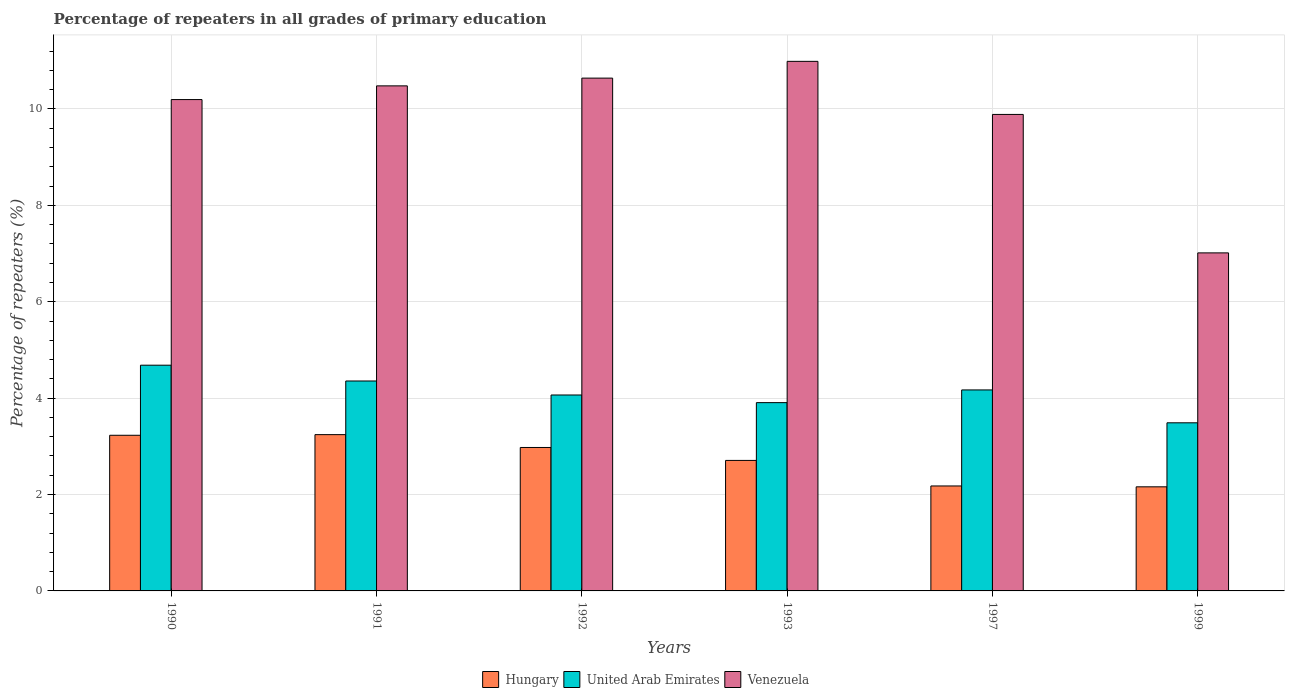How many bars are there on the 5th tick from the right?
Provide a short and direct response. 3. What is the percentage of repeaters in Hungary in 1993?
Your answer should be very brief. 2.71. Across all years, what is the maximum percentage of repeaters in United Arab Emirates?
Make the answer very short. 4.68. Across all years, what is the minimum percentage of repeaters in Hungary?
Your answer should be very brief. 2.16. In which year was the percentage of repeaters in Hungary maximum?
Provide a succinct answer. 1991. In which year was the percentage of repeaters in Venezuela minimum?
Ensure brevity in your answer.  1999. What is the total percentage of repeaters in Venezuela in the graph?
Provide a succinct answer. 59.21. What is the difference between the percentage of repeaters in Hungary in 1992 and that in 1999?
Your answer should be very brief. 0.82. What is the difference between the percentage of repeaters in Venezuela in 1992 and the percentage of repeaters in Hungary in 1999?
Keep it short and to the point. 8.48. What is the average percentage of repeaters in Hungary per year?
Make the answer very short. 2.75. In the year 1991, what is the difference between the percentage of repeaters in Hungary and percentage of repeaters in United Arab Emirates?
Make the answer very short. -1.11. What is the ratio of the percentage of repeaters in United Arab Emirates in 1990 to that in 1992?
Your response must be concise. 1.15. Is the percentage of repeaters in Venezuela in 1992 less than that in 1999?
Your answer should be compact. No. What is the difference between the highest and the second highest percentage of repeaters in United Arab Emirates?
Keep it short and to the point. 0.33. What is the difference between the highest and the lowest percentage of repeaters in United Arab Emirates?
Your response must be concise. 1.2. Is the sum of the percentage of repeaters in Venezuela in 1991 and 1999 greater than the maximum percentage of repeaters in Hungary across all years?
Your answer should be very brief. Yes. What does the 2nd bar from the left in 1999 represents?
Offer a very short reply. United Arab Emirates. What does the 3rd bar from the right in 1990 represents?
Offer a very short reply. Hungary. How many bars are there?
Your response must be concise. 18. Are all the bars in the graph horizontal?
Your answer should be compact. No. How many years are there in the graph?
Provide a short and direct response. 6. What is the difference between two consecutive major ticks on the Y-axis?
Offer a very short reply. 2. Are the values on the major ticks of Y-axis written in scientific E-notation?
Your answer should be compact. No. Does the graph contain any zero values?
Your response must be concise. No. Does the graph contain grids?
Your answer should be compact. Yes. Where does the legend appear in the graph?
Your response must be concise. Bottom center. What is the title of the graph?
Make the answer very short. Percentage of repeaters in all grades of primary education. Does "Kazakhstan" appear as one of the legend labels in the graph?
Ensure brevity in your answer.  No. What is the label or title of the Y-axis?
Give a very brief answer. Percentage of repeaters (%). What is the Percentage of repeaters (%) of Hungary in 1990?
Your answer should be very brief. 3.23. What is the Percentage of repeaters (%) of United Arab Emirates in 1990?
Your answer should be compact. 4.68. What is the Percentage of repeaters (%) in Venezuela in 1990?
Your response must be concise. 10.2. What is the Percentage of repeaters (%) of Hungary in 1991?
Your response must be concise. 3.24. What is the Percentage of repeaters (%) in United Arab Emirates in 1991?
Offer a terse response. 4.36. What is the Percentage of repeaters (%) of Venezuela in 1991?
Keep it short and to the point. 10.48. What is the Percentage of repeaters (%) of Hungary in 1992?
Keep it short and to the point. 2.98. What is the Percentage of repeaters (%) of United Arab Emirates in 1992?
Provide a succinct answer. 4.07. What is the Percentage of repeaters (%) of Venezuela in 1992?
Ensure brevity in your answer.  10.64. What is the Percentage of repeaters (%) of Hungary in 1993?
Provide a short and direct response. 2.71. What is the Percentage of repeaters (%) of United Arab Emirates in 1993?
Make the answer very short. 3.91. What is the Percentage of repeaters (%) in Venezuela in 1993?
Your answer should be compact. 10.99. What is the Percentage of repeaters (%) of Hungary in 1997?
Offer a terse response. 2.18. What is the Percentage of repeaters (%) of United Arab Emirates in 1997?
Offer a very short reply. 4.17. What is the Percentage of repeaters (%) of Venezuela in 1997?
Provide a succinct answer. 9.89. What is the Percentage of repeaters (%) of Hungary in 1999?
Provide a succinct answer. 2.16. What is the Percentage of repeaters (%) in United Arab Emirates in 1999?
Your answer should be compact. 3.49. What is the Percentage of repeaters (%) of Venezuela in 1999?
Ensure brevity in your answer.  7.01. Across all years, what is the maximum Percentage of repeaters (%) in Hungary?
Make the answer very short. 3.24. Across all years, what is the maximum Percentage of repeaters (%) in United Arab Emirates?
Make the answer very short. 4.68. Across all years, what is the maximum Percentage of repeaters (%) in Venezuela?
Provide a short and direct response. 10.99. Across all years, what is the minimum Percentage of repeaters (%) in Hungary?
Your response must be concise. 2.16. Across all years, what is the minimum Percentage of repeaters (%) of United Arab Emirates?
Offer a terse response. 3.49. Across all years, what is the minimum Percentage of repeaters (%) of Venezuela?
Ensure brevity in your answer.  7.01. What is the total Percentage of repeaters (%) of Hungary in the graph?
Provide a short and direct response. 16.5. What is the total Percentage of repeaters (%) of United Arab Emirates in the graph?
Keep it short and to the point. 24.67. What is the total Percentage of repeaters (%) in Venezuela in the graph?
Your answer should be compact. 59.21. What is the difference between the Percentage of repeaters (%) of Hungary in 1990 and that in 1991?
Offer a terse response. -0.01. What is the difference between the Percentage of repeaters (%) of United Arab Emirates in 1990 and that in 1991?
Your response must be concise. 0.33. What is the difference between the Percentage of repeaters (%) in Venezuela in 1990 and that in 1991?
Your answer should be compact. -0.28. What is the difference between the Percentage of repeaters (%) of Hungary in 1990 and that in 1992?
Ensure brevity in your answer.  0.25. What is the difference between the Percentage of repeaters (%) in United Arab Emirates in 1990 and that in 1992?
Give a very brief answer. 0.62. What is the difference between the Percentage of repeaters (%) in Venezuela in 1990 and that in 1992?
Your response must be concise. -0.45. What is the difference between the Percentage of repeaters (%) in Hungary in 1990 and that in 1993?
Provide a short and direct response. 0.52. What is the difference between the Percentage of repeaters (%) of United Arab Emirates in 1990 and that in 1993?
Provide a succinct answer. 0.78. What is the difference between the Percentage of repeaters (%) in Venezuela in 1990 and that in 1993?
Provide a succinct answer. -0.79. What is the difference between the Percentage of repeaters (%) in Hungary in 1990 and that in 1997?
Provide a succinct answer. 1.05. What is the difference between the Percentage of repeaters (%) of United Arab Emirates in 1990 and that in 1997?
Your response must be concise. 0.51. What is the difference between the Percentage of repeaters (%) of Venezuela in 1990 and that in 1997?
Keep it short and to the point. 0.31. What is the difference between the Percentage of repeaters (%) of Hungary in 1990 and that in 1999?
Your answer should be very brief. 1.07. What is the difference between the Percentage of repeaters (%) of United Arab Emirates in 1990 and that in 1999?
Offer a very short reply. 1.2. What is the difference between the Percentage of repeaters (%) in Venezuela in 1990 and that in 1999?
Keep it short and to the point. 3.18. What is the difference between the Percentage of repeaters (%) in Hungary in 1991 and that in 1992?
Your answer should be very brief. 0.27. What is the difference between the Percentage of repeaters (%) of United Arab Emirates in 1991 and that in 1992?
Make the answer very short. 0.29. What is the difference between the Percentage of repeaters (%) of Venezuela in 1991 and that in 1992?
Give a very brief answer. -0.16. What is the difference between the Percentage of repeaters (%) of Hungary in 1991 and that in 1993?
Offer a very short reply. 0.54. What is the difference between the Percentage of repeaters (%) of United Arab Emirates in 1991 and that in 1993?
Provide a succinct answer. 0.45. What is the difference between the Percentage of repeaters (%) of Venezuela in 1991 and that in 1993?
Keep it short and to the point. -0.51. What is the difference between the Percentage of repeaters (%) in Hungary in 1991 and that in 1997?
Offer a very short reply. 1.06. What is the difference between the Percentage of repeaters (%) in United Arab Emirates in 1991 and that in 1997?
Ensure brevity in your answer.  0.19. What is the difference between the Percentage of repeaters (%) in Venezuela in 1991 and that in 1997?
Your answer should be very brief. 0.59. What is the difference between the Percentage of repeaters (%) in Hungary in 1991 and that in 1999?
Your response must be concise. 1.08. What is the difference between the Percentage of repeaters (%) of United Arab Emirates in 1991 and that in 1999?
Keep it short and to the point. 0.87. What is the difference between the Percentage of repeaters (%) of Venezuela in 1991 and that in 1999?
Your answer should be compact. 3.47. What is the difference between the Percentage of repeaters (%) in Hungary in 1992 and that in 1993?
Provide a succinct answer. 0.27. What is the difference between the Percentage of repeaters (%) of United Arab Emirates in 1992 and that in 1993?
Offer a very short reply. 0.16. What is the difference between the Percentage of repeaters (%) of Venezuela in 1992 and that in 1993?
Give a very brief answer. -0.35. What is the difference between the Percentage of repeaters (%) of Hungary in 1992 and that in 1997?
Ensure brevity in your answer.  0.8. What is the difference between the Percentage of repeaters (%) in United Arab Emirates in 1992 and that in 1997?
Your answer should be compact. -0.1. What is the difference between the Percentage of repeaters (%) of Venezuela in 1992 and that in 1997?
Provide a short and direct response. 0.75. What is the difference between the Percentage of repeaters (%) of Hungary in 1992 and that in 1999?
Your answer should be very brief. 0.82. What is the difference between the Percentage of repeaters (%) in United Arab Emirates in 1992 and that in 1999?
Your answer should be compact. 0.58. What is the difference between the Percentage of repeaters (%) of Venezuela in 1992 and that in 1999?
Your answer should be compact. 3.63. What is the difference between the Percentage of repeaters (%) in Hungary in 1993 and that in 1997?
Provide a short and direct response. 0.53. What is the difference between the Percentage of repeaters (%) of United Arab Emirates in 1993 and that in 1997?
Ensure brevity in your answer.  -0.26. What is the difference between the Percentage of repeaters (%) in Venezuela in 1993 and that in 1997?
Give a very brief answer. 1.1. What is the difference between the Percentage of repeaters (%) of Hungary in 1993 and that in 1999?
Your response must be concise. 0.55. What is the difference between the Percentage of repeaters (%) of United Arab Emirates in 1993 and that in 1999?
Provide a short and direct response. 0.42. What is the difference between the Percentage of repeaters (%) in Venezuela in 1993 and that in 1999?
Provide a succinct answer. 3.97. What is the difference between the Percentage of repeaters (%) in Hungary in 1997 and that in 1999?
Your answer should be very brief. 0.02. What is the difference between the Percentage of repeaters (%) in United Arab Emirates in 1997 and that in 1999?
Ensure brevity in your answer.  0.68. What is the difference between the Percentage of repeaters (%) in Venezuela in 1997 and that in 1999?
Give a very brief answer. 2.87. What is the difference between the Percentage of repeaters (%) in Hungary in 1990 and the Percentage of repeaters (%) in United Arab Emirates in 1991?
Make the answer very short. -1.13. What is the difference between the Percentage of repeaters (%) of Hungary in 1990 and the Percentage of repeaters (%) of Venezuela in 1991?
Your answer should be very brief. -7.25. What is the difference between the Percentage of repeaters (%) of United Arab Emirates in 1990 and the Percentage of repeaters (%) of Venezuela in 1991?
Provide a short and direct response. -5.8. What is the difference between the Percentage of repeaters (%) in Hungary in 1990 and the Percentage of repeaters (%) in United Arab Emirates in 1992?
Give a very brief answer. -0.84. What is the difference between the Percentage of repeaters (%) in Hungary in 1990 and the Percentage of repeaters (%) in Venezuela in 1992?
Your response must be concise. -7.41. What is the difference between the Percentage of repeaters (%) in United Arab Emirates in 1990 and the Percentage of repeaters (%) in Venezuela in 1992?
Your response must be concise. -5.96. What is the difference between the Percentage of repeaters (%) in Hungary in 1990 and the Percentage of repeaters (%) in United Arab Emirates in 1993?
Give a very brief answer. -0.68. What is the difference between the Percentage of repeaters (%) in Hungary in 1990 and the Percentage of repeaters (%) in Venezuela in 1993?
Make the answer very short. -7.76. What is the difference between the Percentage of repeaters (%) in United Arab Emirates in 1990 and the Percentage of repeaters (%) in Venezuela in 1993?
Make the answer very short. -6.3. What is the difference between the Percentage of repeaters (%) of Hungary in 1990 and the Percentage of repeaters (%) of United Arab Emirates in 1997?
Provide a succinct answer. -0.94. What is the difference between the Percentage of repeaters (%) in Hungary in 1990 and the Percentage of repeaters (%) in Venezuela in 1997?
Keep it short and to the point. -6.66. What is the difference between the Percentage of repeaters (%) of United Arab Emirates in 1990 and the Percentage of repeaters (%) of Venezuela in 1997?
Give a very brief answer. -5.2. What is the difference between the Percentage of repeaters (%) of Hungary in 1990 and the Percentage of repeaters (%) of United Arab Emirates in 1999?
Give a very brief answer. -0.26. What is the difference between the Percentage of repeaters (%) of Hungary in 1990 and the Percentage of repeaters (%) of Venezuela in 1999?
Ensure brevity in your answer.  -3.78. What is the difference between the Percentage of repeaters (%) in United Arab Emirates in 1990 and the Percentage of repeaters (%) in Venezuela in 1999?
Keep it short and to the point. -2.33. What is the difference between the Percentage of repeaters (%) of Hungary in 1991 and the Percentage of repeaters (%) of United Arab Emirates in 1992?
Offer a terse response. -0.82. What is the difference between the Percentage of repeaters (%) of Hungary in 1991 and the Percentage of repeaters (%) of Venezuela in 1992?
Your answer should be very brief. -7.4. What is the difference between the Percentage of repeaters (%) in United Arab Emirates in 1991 and the Percentage of repeaters (%) in Venezuela in 1992?
Provide a short and direct response. -6.28. What is the difference between the Percentage of repeaters (%) of Hungary in 1991 and the Percentage of repeaters (%) of United Arab Emirates in 1993?
Your response must be concise. -0.66. What is the difference between the Percentage of repeaters (%) in Hungary in 1991 and the Percentage of repeaters (%) in Venezuela in 1993?
Keep it short and to the point. -7.75. What is the difference between the Percentage of repeaters (%) of United Arab Emirates in 1991 and the Percentage of repeaters (%) of Venezuela in 1993?
Give a very brief answer. -6.63. What is the difference between the Percentage of repeaters (%) of Hungary in 1991 and the Percentage of repeaters (%) of United Arab Emirates in 1997?
Provide a succinct answer. -0.93. What is the difference between the Percentage of repeaters (%) of Hungary in 1991 and the Percentage of repeaters (%) of Venezuela in 1997?
Keep it short and to the point. -6.64. What is the difference between the Percentage of repeaters (%) in United Arab Emirates in 1991 and the Percentage of repeaters (%) in Venezuela in 1997?
Keep it short and to the point. -5.53. What is the difference between the Percentage of repeaters (%) of Hungary in 1991 and the Percentage of repeaters (%) of United Arab Emirates in 1999?
Your response must be concise. -0.25. What is the difference between the Percentage of repeaters (%) of Hungary in 1991 and the Percentage of repeaters (%) of Venezuela in 1999?
Make the answer very short. -3.77. What is the difference between the Percentage of repeaters (%) of United Arab Emirates in 1991 and the Percentage of repeaters (%) of Venezuela in 1999?
Your answer should be very brief. -2.66. What is the difference between the Percentage of repeaters (%) of Hungary in 1992 and the Percentage of repeaters (%) of United Arab Emirates in 1993?
Your response must be concise. -0.93. What is the difference between the Percentage of repeaters (%) of Hungary in 1992 and the Percentage of repeaters (%) of Venezuela in 1993?
Make the answer very short. -8.01. What is the difference between the Percentage of repeaters (%) of United Arab Emirates in 1992 and the Percentage of repeaters (%) of Venezuela in 1993?
Keep it short and to the point. -6.92. What is the difference between the Percentage of repeaters (%) of Hungary in 1992 and the Percentage of repeaters (%) of United Arab Emirates in 1997?
Keep it short and to the point. -1.19. What is the difference between the Percentage of repeaters (%) in Hungary in 1992 and the Percentage of repeaters (%) in Venezuela in 1997?
Offer a terse response. -6.91. What is the difference between the Percentage of repeaters (%) of United Arab Emirates in 1992 and the Percentage of repeaters (%) of Venezuela in 1997?
Offer a very short reply. -5.82. What is the difference between the Percentage of repeaters (%) of Hungary in 1992 and the Percentage of repeaters (%) of United Arab Emirates in 1999?
Your answer should be compact. -0.51. What is the difference between the Percentage of repeaters (%) of Hungary in 1992 and the Percentage of repeaters (%) of Venezuela in 1999?
Offer a terse response. -4.04. What is the difference between the Percentage of repeaters (%) of United Arab Emirates in 1992 and the Percentage of repeaters (%) of Venezuela in 1999?
Provide a short and direct response. -2.95. What is the difference between the Percentage of repeaters (%) of Hungary in 1993 and the Percentage of repeaters (%) of United Arab Emirates in 1997?
Your answer should be very brief. -1.46. What is the difference between the Percentage of repeaters (%) in Hungary in 1993 and the Percentage of repeaters (%) in Venezuela in 1997?
Your response must be concise. -7.18. What is the difference between the Percentage of repeaters (%) of United Arab Emirates in 1993 and the Percentage of repeaters (%) of Venezuela in 1997?
Provide a succinct answer. -5.98. What is the difference between the Percentage of repeaters (%) in Hungary in 1993 and the Percentage of repeaters (%) in United Arab Emirates in 1999?
Your answer should be very brief. -0.78. What is the difference between the Percentage of repeaters (%) of Hungary in 1993 and the Percentage of repeaters (%) of Venezuela in 1999?
Your response must be concise. -4.31. What is the difference between the Percentage of repeaters (%) of United Arab Emirates in 1993 and the Percentage of repeaters (%) of Venezuela in 1999?
Ensure brevity in your answer.  -3.11. What is the difference between the Percentage of repeaters (%) of Hungary in 1997 and the Percentage of repeaters (%) of United Arab Emirates in 1999?
Offer a terse response. -1.31. What is the difference between the Percentage of repeaters (%) in Hungary in 1997 and the Percentage of repeaters (%) in Venezuela in 1999?
Provide a short and direct response. -4.84. What is the difference between the Percentage of repeaters (%) in United Arab Emirates in 1997 and the Percentage of repeaters (%) in Venezuela in 1999?
Your response must be concise. -2.84. What is the average Percentage of repeaters (%) in Hungary per year?
Your answer should be compact. 2.75. What is the average Percentage of repeaters (%) in United Arab Emirates per year?
Your answer should be very brief. 4.11. What is the average Percentage of repeaters (%) in Venezuela per year?
Your answer should be very brief. 9.87. In the year 1990, what is the difference between the Percentage of repeaters (%) of Hungary and Percentage of repeaters (%) of United Arab Emirates?
Make the answer very short. -1.45. In the year 1990, what is the difference between the Percentage of repeaters (%) in Hungary and Percentage of repeaters (%) in Venezuela?
Your answer should be very brief. -6.97. In the year 1990, what is the difference between the Percentage of repeaters (%) in United Arab Emirates and Percentage of repeaters (%) in Venezuela?
Make the answer very short. -5.51. In the year 1991, what is the difference between the Percentage of repeaters (%) of Hungary and Percentage of repeaters (%) of United Arab Emirates?
Make the answer very short. -1.11. In the year 1991, what is the difference between the Percentage of repeaters (%) of Hungary and Percentage of repeaters (%) of Venezuela?
Give a very brief answer. -7.24. In the year 1991, what is the difference between the Percentage of repeaters (%) of United Arab Emirates and Percentage of repeaters (%) of Venezuela?
Offer a terse response. -6.12. In the year 1992, what is the difference between the Percentage of repeaters (%) in Hungary and Percentage of repeaters (%) in United Arab Emirates?
Make the answer very short. -1.09. In the year 1992, what is the difference between the Percentage of repeaters (%) in Hungary and Percentage of repeaters (%) in Venezuela?
Provide a short and direct response. -7.66. In the year 1992, what is the difference between the Percentage of repeaters (%) of United Arab Emirates and Percentage of repeaters (%) of Venezuela?
Your response must be concise. -6.58. In the year 1993, what is the difference between the Percentage of repeaters (%) in Hungary and Percentage of repeaters (%) in United Arab Emirates?
Offer a very short reply. -1.2. In the year 1993, what is the difference between the Percentage of repeaters (%) of Hungary and Percentage of repeaters (%) of Venezuela?
Make the answer very short. -8.28. In the year 1993, what is the difference between the Percentage of repeaters (%) of United Arab Emirates and Percentage of repeaters (%) of Venezuela?
Offer a terse response. -7.08. In the year 1997, what is the difference between the Percentage of repeaters (%) of Hungary and Percentage of repeaters (%) of United Arab Emirates?
Provide a short and direct response. -1.99. In the year 1997, what is the difference between the Percentage of repeaters (%) of Hungary and Percentage of repeaters (%) of Venezuela?
Your answer should be compact. -7.71. In the year 1997, what is the difference between the Percentage of repeaters (%) of United Arab Emirates and Percentage of repeaters (%) of Venezuela?
Your answer should be compact. -5.72. In the year 1999, what is the difference between the Percentage of repeaters (%) in Hungary and Percentage of repeaters (%) in United Arab Emirates?
Make the answer very short. -1.33. In the year 1999, what is the difference between the Percentage of repeaters (%) in Hungary and Percentage of repeaters (%) in Venezuela?
Offer a very short reply. -4.85. In the year 1999, what is the difference between the Percentage of repeaters (%) in United Arab Emirates and Percentage of repeaters (%) in Venezuela?
Provide a short and direct response. -3.53. What is the ratio of the Percentage of repeaters (%) in United Arab Emirates in 1990 to that in 1991?
Offer a terse response. 1.08. What is the ratio of the Percentage of repeaters (%) in Venezuela in 1990 to that in 1991?
Your answer should be very brief. 0.97. What is the ratio of the Percentage of repeaters (%) of Hungary in 1990 to that in 1992?
Your answer should be very brief. 1.08. What is the ratio of the Percentage of repeaters (%) of United Arab Emirates in 1990 to that in 1992?
Ensure brevity in your answer.  1.15. What is the ratio of the Percentage of repeaters (%) of Venezuela in 1990 to that in 1992?
Ensure brevity in your answer.  0.96. What is the ratio of the Percentage of repeaters (%) of Hungary in 1990 to that in 1993?
Give a very brief answer. 1.19. What is the ratio of the Percentage of repeaters (%) of United Arab Emirates in 1990 to that in 1993?
Give a very brief answer. 1.2. What is the ratio of the Percentage of repeaters (%) of Venezuela in 1990 to that in 1993?
Your answer should be compact. 0.93. What is the ratio of the Percentage of repeaters (%) of Hungary in 1990 to that in 1997?
Your response must be concise. 1.48. What is the ratio of the Percentage of repeaters (%) of United Arab Emirates in 1990 to that in 1997?
Keep it short and to the point. 1.12. What is the ratio of the Percentage of repeaters (%) in Venezuela in 1990 to that in 1997?
Your response must be concise. 1.03. What is the ratio of the Percentage of repeaters (%) of Hungary in 1990 to that in 1999?
Make the answer very short. 1.5. What is the ratio of the Percentage of repeaters (%) of United Arab Emirates in 1990 to that in 1999?
Give a very brief answer. 1.34. What is the ratio of the Percentage of repeaters (%) in Venezuela in 1990 to that in 1999?
Your answer should be very brief. 1.45. What is the ratio of the Percentage of repeaters (%) in Hungary in 1991 to that in 1992?
Make the answer very short. 1.09. What is the ratio of the Percentage of repeaters (%) of United Arab Emirates in 1991 to that in 1992?
Give a very brief answer. 1.07. What is the ratio of the Percentage of repeaters (%) in Venezuela in 1991 to that in 1992?
Offer a terse response. 0.98. What is the ratio of the Percentage of repeaters (%) of Hungary in 1991 to that in 1993?
Ensure brevity in your answer.  1.2. What is the ratio of the Percentage of repeaters (%) in United Arab Emirates in 1991 to that in 1993?
Provide a short and direct response. 1.11. What is the ratio of the Percentage of repeaters (%) in Venezuela in 1991 to that in 1993?
Provide a short and direct response. 0.95. What is the ratio of the Percentage of repeaters (%) of Hungary in 1991 to that in 1997?
Your answer should be very brief. 1.49. What is the ratio of the Percentage of repeaters (%) of United Arab Emirates in 1991 to that in 1997?
Offer a terse response. 1.04. What is the ratio of the Percentage of repeaters (%) of Venezuela in 1991 to that in 1997?
Your answer should be compact. 1.06. What is the ratio of the Percentage of repeaters (%) of Hungary in 1991 to that in 1999?
Ensure brevity in your answer.  1.5. What is the ratio of the Percentage of repeaters (%) of United Arab Emirates in 1991 to that in 1999?
Your answer should be compact. 1.25. What is the ratio of the Percentage of repeaters (%) of Venezuela in 1991 to that in 1999?
Your answer should be very brief. 1.49. What is the ratio of the Percentage of repeaters (%) of Hungary in 1992 to that in 1993?
Ensure brevity in your answer.  1.1. What is the ratio of the Percentage of repeaters (%) of United Arab Emirates in 1992 to that in 1993?
Provide a succinct answer. 1.04. What is the ratio of the Percentage of repeaters (%) of Venezuela in 1992 to that in 1993?
Offer a terse response. 0.97. What is the ratio of the Percentage of repeaters (%) of Hungary in 1992 to that in 1997?
Your answer should be very brief. 1.37. What is the ratio of the Percentage of repeaters (%) of United Arab Emirates in 1992 to that in 1997?
Your answer should be compact. 0.97. What is the ratio of the Percentage of repeaters (%) in Venezuela in 1992 to that in 1997?
Offer a terse response. 1.08. What is the ratio of the Percentage of repeaters (%) of Hungary in 1992 to that in 1999?
Make the answer very short. 1.38. What is the ratio of the Percentage of repeaters (%) of United Arab Emirates in 1992 to that in 1999?
Give a very brief answer. 1.17. What is the ratio of the Percentage of repeaters (%) of Venezuela in 1992 to that in 1999?
Provide a short and direct response. 1.52. What is the ratio of the Percentage of repeaters (%) in Hungary in 1993 to that in 1997?
Keep it short and to the point. 1.24. What is the ratio of the Percentage of repeaters (%) in United Arab Emirates in 1993 to that in 1997?
Provide a short and direct response. 0.94. What is the ratio of the Percentage of repeaters (%) of Venezuela in 1993 to that in 1997?
Your response must be concise. 1.11. What is the ratio of the Percentage of repeaters (%) of Hungary in 1993 to that in 1999?
Offer a terse response. 1.25. What is the ratio of the Percentage of repeaters (%) of United Arab Emirates in 1993 to that in 1999?
Provide a succinct answer. 1.12. What is the ratio of the Percentage of repeaters (%) of Venezuela in 1993 to that in 1999?
Offer a terse response. 1.57. What is the ratio of the Percentage of repeaters (%) of Hungary in 1997 to that in 1999?
Your answer should be very brief. 1.01. What is the ratio of the Percentage of repeaters (%) in United Arab Emirates in 1997 to that in 1999?
Your answer should be very brief. 1.2. What is the ratio of the Percentage of repeaters (%) of Venezuela in 1997 to that in 1999?
Your response must be concise. 1.41. What is the difference between the highest and the second highest Percentage of repeaters (%) in Hungary?
Your answer should be compact. 0.01. What is the difference between the highest and the second highest Percentage of repeaters (%) in United Arab Emirates?
Provide a short and direct response. 0.33. What is the difference between the highest and the second highest Percentage of repeaters (%) in Venezuela?
Offer a very short reply. 0.35. What is the difference between the highest and the lowest Percentage of repeaters (%) of Hungary?
Offer a very short reply. 1.08. What is the difference between the highest and the lowest Percentage of repeaters (%) in United Arab Emirates?
Offer a very short reply. 1.2. What is the difference between the highest and the lowest Percentage of repeaters (%) of Venezuela?
Offer a terse response. 3.97. 